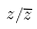<formula> <loc_0><loc_0><loc_500><loc_500>z / \overline { z }</formula> 